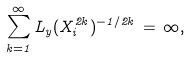Convert formula to latex. <formula><loc_0><loc_0><loc_500><loc_500>\sum _ { k = 1 } ^ { \infty } L _ { y } ( X _ { i } ^ { 2 k } ) ^ { - 1 / 2 k } \, = \, \infty ,</formula> 